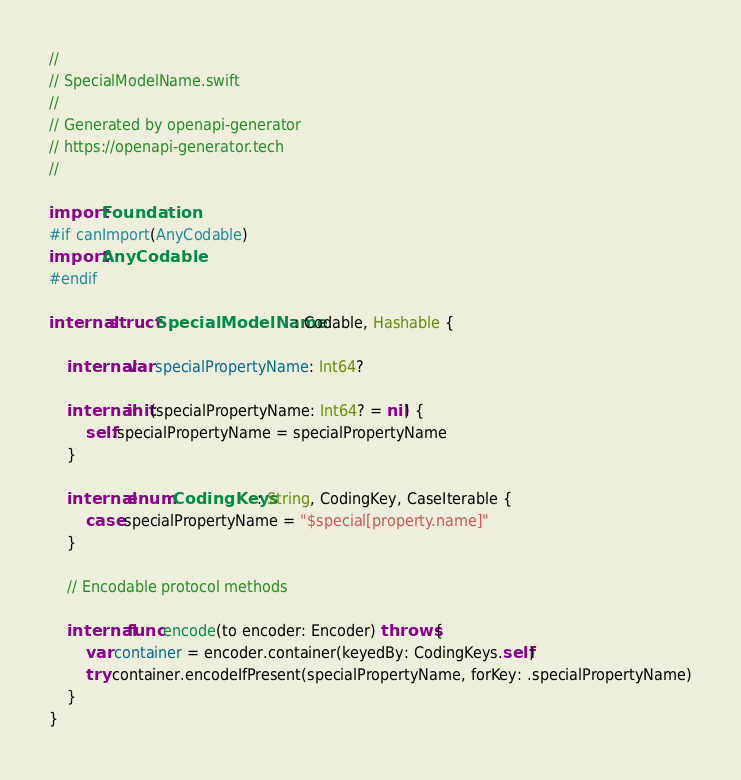<code> <loc_0><loc_0><loc_500><loc_500><_Swift_>//
// SpecialModelName.swift
//
// Generated by openapi-generator
// https://openapi-generator.tech
//

import Foundation
#if canImport(AnyCodable)
import AnyCodable
#endif

internal struct SpecialModelName: Codable, Hashable {

    internal var specialPropertyName: Int64?

    internal init(specialPropertyName: Int64? = nil) {
        self.specialPropertyName = specialPropertyName
    }

    internal enum CodingKeys: String, CodingKey, CaseIterable {
        case specialPropertyName = "$special[property.name]"
    }

    // Encodable protocol methods

    internal func encode(to encoder: Encoder) throws {
        var container = encoder.container(keyedBy: CodingKeys.self)
        try container.encodeIfPresent(specialPropertyName, forKey: .specialPropertyName)
    }
}
</code> 